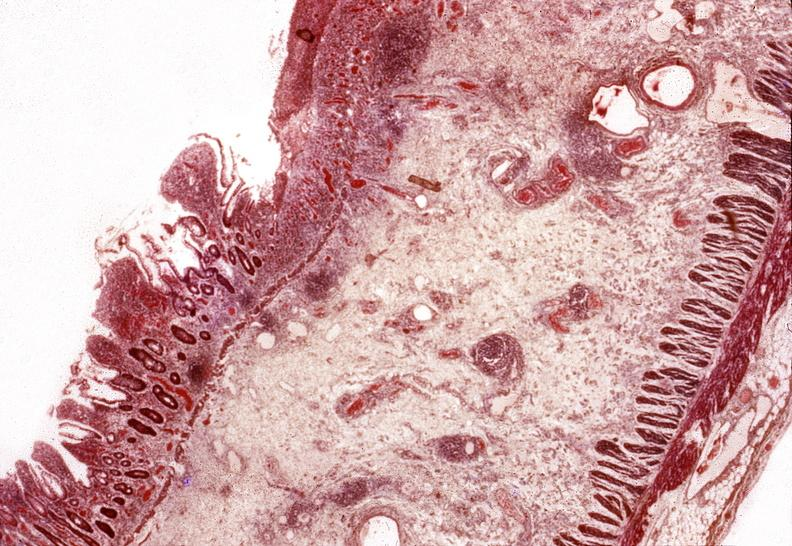where is this from?
Answer the question using a single word or phrase. Gastrointestinal system 